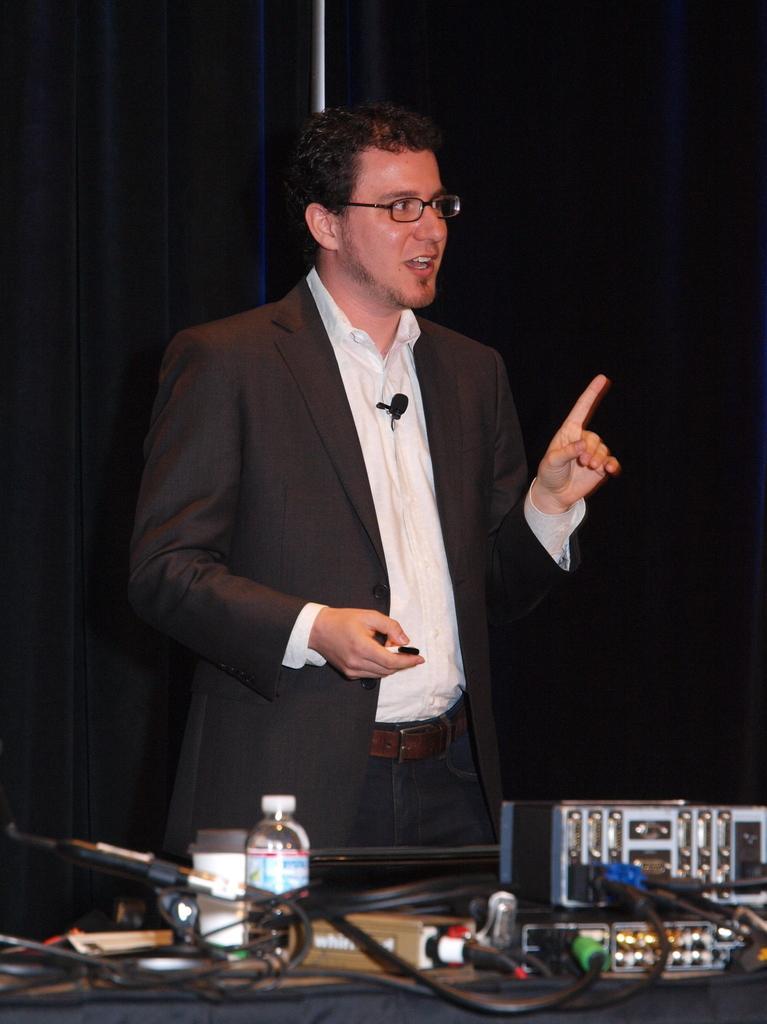Can you describe this image briefly? In this image there is a person standing by holding some object in his hand in front of the person on the table there are a few electrical equipment with cables and there is a coffee mug and a bottle of water, behind the person there is a curtain. 